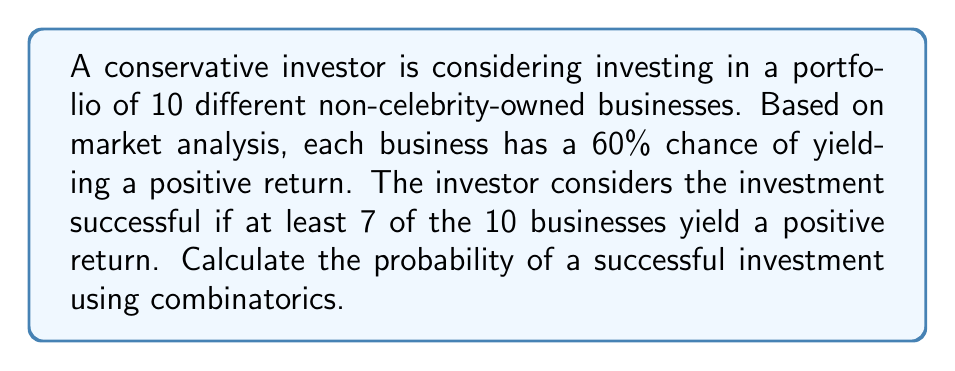Provide a solution to this math problem. To solve this problem, we'll use the binomial probability formula and combinatorics. Let's break it down step-by-step:

1) We can model this scenario as a binomial distribution with the following parameters:
   $n = 10$ (total number of businesses)
   $p = 0.60$ (probability of success for each business)
   $k \geq 7$ (we want at least 7 successes)

2) The probability of exactly $k$ successes in $n$ trials is given by the binomial probability formula:

   $$P(X = k) = \binom{n}{k} p^k (1-p)^{n-k}$$

3) We need to calculate this for $k = 7$, $k = 8$, $k = 9$, and $k = 10$, and then sum these probabilities.

4) Let's calculate each probability:

   For $k = 7$:
   $$P(X = 7) = \binom{10}{7} (0.60)^7 (0.40)^3 = 120 \cdot 0.0279936 \cdot 0.064 = 0.2150348800$$

   For $k = 8$:
   $$P(X = 8) = \binom{10}{8} (0.60)^8 (0.40)^2 = 45 \cdot 0.0466560 \cdot 0.16 = 0.3359232000$$

   For $k = 9$:
   $$P(X = 9) = \binom{10}{9} (0.60)^9 (0.40)^1 = 10 \cdot 0.0777600 \cdot 0.40 = 0.3110400000$$

   For $k = 10$:
   $$P(X = 10) = \binom{10}{10} (0.60)^{10} (0.40)^0 = 1 \cdot 0.0604661440 \cdot 1 = 0.0604661440$$

5) The total probability of a successful investment (at least 7 businesses yielding a positive return) is the sum of these probabilities:

   $$P(X \geq 7) = P(X = 7) + P(X = 8) + P(X = 9) + P(X = 10)$$
   $$= 0.2150348800 + 0.3359232000 + 0.3110400000 + 0.0604661440$$
   $$= 0.9224642240$$
Answer: The probability of a successful investment is approximately 0.9225 or 92.25%. 